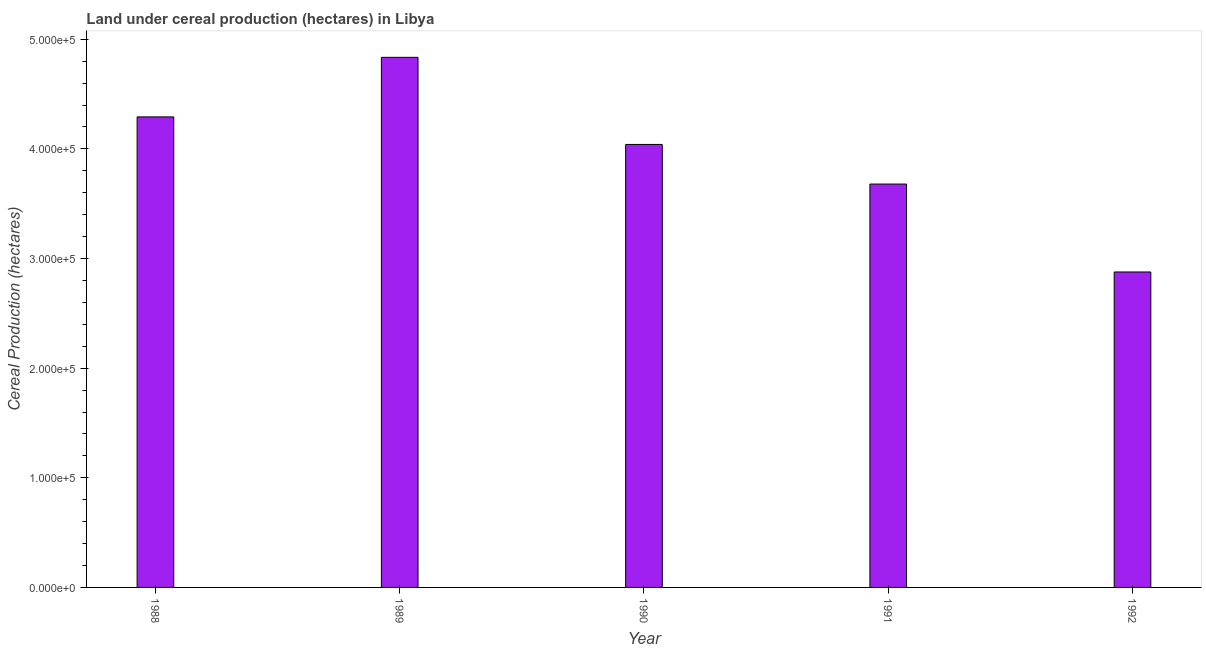Does the graph contain any zero values?
Make the answer very short. No. Does the graph contain grids?
Provide a short and direct response. No. What is the title of the graph?
Your response must be concise. Land under cereal production (hectares) in Libya. What is the label or title of the X-axis?
Offer a very short reply. Year. What is the label or title of the Y-axis?
Make the answer very short. Cereal Production (hectares). What is the land under cereal production in 1992?
Keep it short and to the point. 2.88e+05. Across all years, what is the maximum land under cereal production?
Offer a terse response. 4.84e+05. Across all years, what is the minimum land under cereal production?
Offer a very short reply. 2.88e+05. In which year was the land under cereal production maximum?
Ensure brevity in your answer.  1989. What is the sum of the land under cereal production?
Offer a terse response. 1.97e+06. What is the difference between the land under cereal production in 1991 and 1992?
Ensure brevity in your answer.  8.02e+04. What is the average land under cereal production per year?
Your answer should be very brief. 3.94e+05. What is the median land under cereal production?
Provide a short and direct response. 4.04e+05. In how many years, is the land under cereal production greater than 380000 hectares?
Give a very brief answer. 3. Do a majority of the years between 1991 and 1990 (inclusive) have land under cereal production greater than 280000 hectares?
Offer a very short reply. No. What is the ratio of the land under cereal production in 1989 to that in 1991?
Make the answer very short. 1.31. Is the land under cereal production in 1990 less than that in 1991?
Offer a very short reply. No. Is the difference between the land under cereal production in 1989 and 1991 greater than the difference between any two years?
Your response must be concise. No. What is the difference between the highest and the second highest land under cereal production?
Provide a succinct answer. 5.43e+04. What is the difference between the highest and the lowest land under cereal production?
Offer a terse response. 1.96e+05. Are all the bars in the graph horizontal?
Ensure brevity in your answer.  No. Are the values on the major ticks of Y-axis written in scientific E-notation?
Your answer should be compact. Yes. What is the Cereal Production (hectares) in 1988?
Your answer should be very brief. 4.29e+05. What is the Cereal Production (hectares) in 1989?
Offer a terse response. 4.84e+05. What is the Cereal Production (hectares) of 1990?
Make the answer very short. 4.04e+05. What is the Cereal Production (hectares) of 1991?
Give a very brief answer. 3.68e+05. What is the Cereal Production (hectares) of 1992?
Offer a terse response. 2.88e+05. What is the difference between the Cereal Production (hectares) in 1988 and 1989?
Your answer should be compact. -5.43e+04. What is the difference between the Cereal Production (hectares) in 1988 and 1990?
Offer a very short reply. 2.51e+04. What is the difference between the Cereal Production (hectares) in 1988 and 1991?
Offer a very short reply. 6.13e+04. What is the difference between the Cereal Production (hectares) in 1988 and 1992?
Give a very brief answer. 1.41e+05. What is the difference between the Cereal Production (hectares) in 1989 and 1990?
Keep it short and to the point. 7.95e+04. What is the difference between the Cereal Production (hectares) in 1989 and 1991?
Offer a terse response. 1.16e+05. What is the difference between the Cereal Production (hectares) in 1989 and 1992?
Offer a very short reply. 1.96e+05. What is the difference between the Cereal Production (hectares) in 1990 and 1991?
Offer a terse response. 3.61e+04. What is the difference between the Cereal Production (hectares) in 1990 and 1992?
Provide a short and direct response. 1.16e+05. What is the difference between the Cereal Production (hectares) in 1991 and 1992?
Your answer should be very brief. 8.02e+04. What is the ratio of the Cereal Production (hectares) in 1988 to that in 1989?
Provide a succinct answer. 0.89. What is the ratio of the Cereal Production (hectares) in 1988 to that in 1990?
Ensure brevity in your answer.  1.06. What is the ratio of the Cereal Production (hectares) in 1988 to that in 1991?
Offer a very short reply. 1.17. What is the ratio of the Cereal Production (hectares) in 1988 to that in 1992?
Offer a terse response. 1.49. What is the ratio of the Cereal Production (hectares) in 1989 to that in 1990?
Offer a terse response. 1.2. What is the ratio of the Cereal Production (hectares) in 1989 to that in 1991?
Keep it short and to the point. 1.31. What is the ratio of the Cereal Production (hectares) in 1989 to that in 1992?
Your answer should be compact. 1.68. What is the ratio of the Cereal Production (hectares) in 1990 to that in 1991?
Your answer should be very brief. 1.1. What is the ratio of the Cereal Production (hectares) in 1990 to that in 1992?
Provide a succinct answer. 1.4. What is the ratio of the Cereal Production (hectares) in 1991 to that in 1992?
Ensure brevity in your answer.  1.28. 